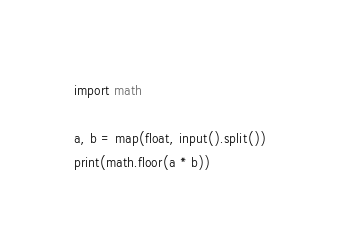Convert code to text. <code><loc_0><loc_0><loc_500><loc_500><_Python_>import math

a, b = map(float, input().split())
print(math.floor(a * b))
</code> 